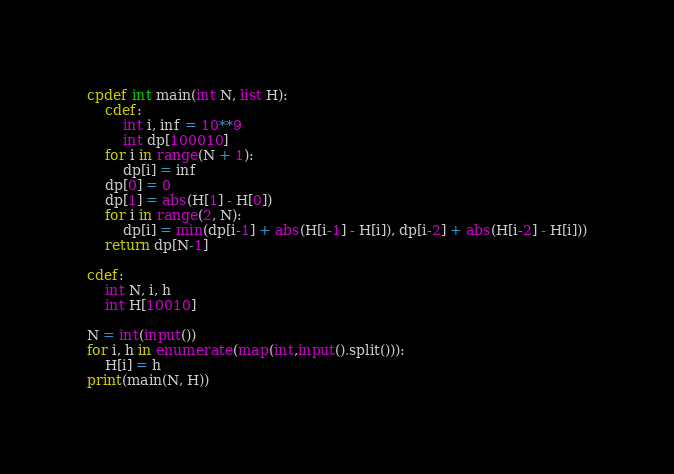Convert code to text. <code><loc_0><loc_0><loc_500><loc_500><_Cython_>cpdef int main(int N, list H):
    cdef:
        int i, inf = 10**9
        int dp[100010]
    for i in range(N + 1):
        dp[i] = inf
    dp[0] = 0
    dp[1] = abs(H[1] - H[0])
    for i in range(2, N):
        dp[i] = min(dp[i-1] + abs(H[i-1] - H[i]), dp[i-2] + abs(H[i-2] - H[i]))
    return dp[N-1]

cdef:
    int N, i, h
    int H[10010]

N = int(input())
for i, h in enumerate(map(int,input().split())):
    H[i] = h
print(main(N, H))

</code> 